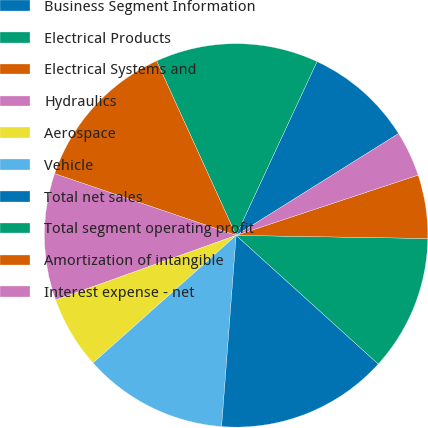Convert chart. <chart><loc_0><loc_0><loc_500><loc_500><pie_chart><fcel>Business Segment Information<fcel>Electrical Products<fcel>Electrical Systems and<fcel>Hydraulics<fcel>Aerospace<fcel>Vehicle<fcel>Total net sales<fcel>Total segment operating profit<fcel>Amortization of intangible<fcel>Interest expense - net<nl><fcel>9.16%<fcel>13.74%<fcel>12.98%<fcel>10.69%<fcel>6.11%<fcel>12.21%<fcel>14.5%<fcel>11.45%<fcel>5.35%<fcel>3.82%<nl></chart> 